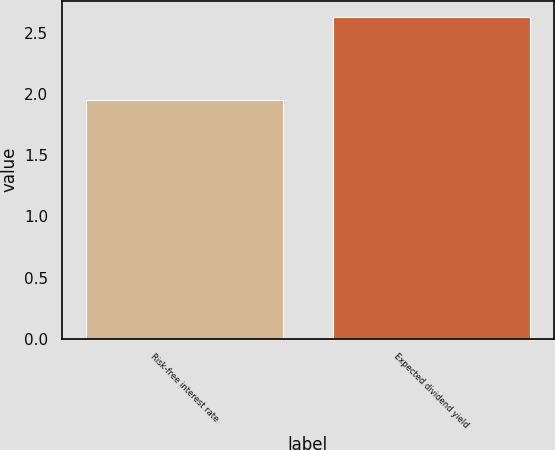<chart> <loc_0><loc_0><loc_500><loc_500><bar_chart><fcel>Risk-free interest rate<fcel>Expected dividend yield<nl><fcel>1.95<fcel>2.63<nl></chart> 